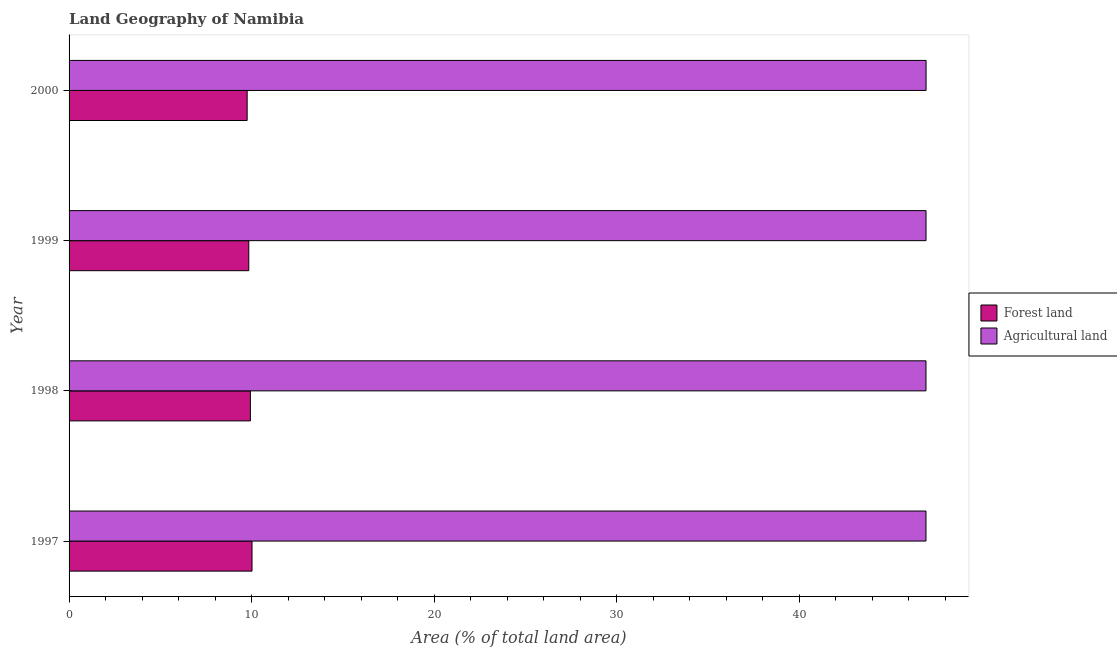How many different coloured bars are there?
Your answer should be compact. 2. Are the number of bars per tick equal to the number of legend labels?
Ensure brevity in your answer.  Yes. How many bars are there on the 4th tick from the bottom?
Make the answer very short. 2. What is the percentage of land area under forests in 1999?
Ensure brevity in your answer.  9.84. Across all years, what is the maximum percentage of land area under agriculture?
Make the answer very short. 46.95. Across all years, what is the minimum percentage of land area under agriculture?
Your answer should be compact. 46.94. In which year was the percentage of land area under agriculture maximum?
Your answer should be compact. 2000. What is the total percentage of land area under forests in the graph?
Your response must be concise. 39.56. What is the difference between the percentage of land area under forests in 1999 and that in 2000?
Keep it short and to the point. 0.09. What is the difference between the percentage of land area under agriculture in 1998 and the percentage of land area under forests in 1997?
Provide a short and direct response. 36.92. What is the average percentage of land area under agriculture per year?
Provide a succinct answer. 46.95. In the year 1999, what is the difference between the percentage of land area under forests and percentage of land area under agriculture?
Keep it short and to the point. -37.1. What is the ratio of the percentage of land area under forests in 1997 to that in 1999?
Your answer should be compact. 1.02. What is the difference between the highest and the second highest percentage of land area under agriculture?
Make the answer very short. 0. Is the sum of the percentage of land area under agriculture in 1998 and 1999 greater than the maximum percentage of land area under forests across all years?
Give a very brief answer. Yes. What does the 2nd bar from the top in 1998 represents?
Keep it short and to the point. Forest land. What does the 2nd bar from the bottom in 2000 represents?
Provide a short and direct response. Agricultural land. How many bars are there?
Keep it short and to the point. 8. Are all the bars in the graph horizontal?
Your answer should be very brief. Yes. How many years are there in the graph?
Your response must be concise. 4. Are the values on the major ticks of X-axis written in scientific E-notation?
Offer a terse response. No. Does the graph contain any zero values?
Your answer should be very brief. No. How are the legend labels stacked?
Your response must be concise. Vertical. What is the title of the graph?
Offer a very short reply. Land Geography of Namibia. What is the label or title of the X-axis?
Offer a terse response. Area (% of total land area). What is the Area (% of total land area) of Forest land in 1997?
Make the answer very short. 10.02. What is the Area (% of total land area) in Agricultural land in 1997?
Your response must be concise. 46.94. What is the Area (% of total land area) of Forest land in 1998?
Offer a terse response. 9.93. What is the Area (% of total land area) of Agricultural land in 1998?
Your answer should be very brief. 46.94. What is the Area (% of total land area) in Forest land in 1999?
Offer a very short reply. 9.84. What is the Area (% of total land area) in Agricultural land in 1999?
Keep it short and to the point. 46.95. What is the Area (% of total land area) of Forest land in 2000?
Your response must be concise. 9.76. What is the Area (% of total land area) of Agricultural land in 2000?
Ensure brevity in your answer.  46.95. Across all years, what is the maximum Area (% of total land area) in Forest land?
Keep it short and to the point. 10.02. Across all years, what is the maximum Area (% of total land area) of Agricultural land?
Your response must be concise. 46.95. Across all years, what is the minimum Area (% of total land area) of Forest land?
Your answer should be very brief. 9.76. Across all years, what is the minimum Area (% of total land area) of Agricultural land?
Keep it short and to the point. 46.94. What is the total Area (% of total land area) in Forest land in the graph?
Your answer should be very brief. 39.56. What is the total Area (% of total land area) in Agricultural land in the graph?
Your response must be concise. 187.79. What is the difference between the Area (% of total land area) of Forest land in 1997 and that in 1998?
Your answer should be compact. 0.09. What is the difference between the Area (% of total land area) of Agricultural land in 1997 and that in 1998?
Keep it short and to the point. 0. What is the difference between the Area (% of total land area) of Forest land in 1997 and that in 1999?
Offer a terse response. 0.18. What is the difference between the Area (% of total land area) in Agricultural land in 1997 and that in 1999?
Give a very brief answer. -0. What is the difference between the Area (% of total land area) in Forest land in 1997 and that in 2000?
Your answer should be very brief. 0.27. What is the difference between the Area (% of total land area) of Agricultural land in 1997 and that in 2000?
Offer a terse response. -0. What is the difference between the Area (% of total land area) in Forest land in 1998 and that in 1999?
Offer a terse response. 0.09. What is the difference between the Area (% of total land area) in Agricultural land in 1998 and that in 1999?
Provide a short and direct response. -0. What is the difference between the Area (% of total land area) of Forest land in 1998 and that in 2000?
Your response must be concise. 0.18. What is the difference between the Area (% of total land area) of Agricultural land in 1998 and that in 2000?
Give a very brief answer. -0. What is the difference between the Area (% of total land area) in Forest land in 1999 and that in 2000?
Ensure brevity in your answer.  0.09. What is the difference between the Area (% of total land area) of Agricultural land in 1999 and that in 2000?
Your answer should be very brief. -0. What is the difference between the Area (% of total land area) in Forest land in 1997 and the Area (% of total land area) in Agricultural land in 1998?
Your response must be concise. -36.92. What is the difference between the Area (% of total land area) in Forest land in 1997 and the Area (% of total land area) in Agricultural land in 1999?
Make the answer very short. -36.92. What is the difference between the Area (% of total land area) in Forest land in 1997 and the Area (% of total land area) in Agricultural land in 2000?
Keep it short and to the point. -36.93. What is the difference between the Area (% of total land area) of Forest land in 1998 and the Area (% of total land area) of Agricultural land in 1999?
Your response must be concise. -37.01. What is the difference between the Area (% of total land area) in Forest land in 1998 and the Area (% of total land area) in Agricultural land in 2000?
Give a very brief answer. -37.02. What is the difference between the Area (% of total land area) in Forest land in 1999 and the Area (% of total land area) in Agricultural land in 2000?
Offer a terse response. -37.1. What is the average Area (% of total land area) in Forest land per year?
Keep it short and to the point. 9.89. What is the average Area (% of total land area) of Agricultural land per year?
Give a very brief answer. 46.95. In the year 1997, what is the difference between the Area (% of total land area) in Forest land and Area (% of total land area) in Agricultural land?
Make the answer very short. -36.92. In the year 1998, what is the difference between the Area (% of total land area) of Forest land and Area (% of total land area) of Agricultural land?
Offer a very short reply. -37.01. In the year 1999, what is the difference between the Area (% of total land area) in Forest land and Area (% of total land area) in Agricultural land?
Your response must be concise. -37.1. In the year 2000, what is the difference between the Area (% of total land area) of Forest land and Area (% of total land area) of Agricultural land?
Offer a terse response. -37.19. What is the ratio of the Area (% of total land area) of Forest land in 1997 to that in 1998?
Keep it short and to the point. 1.01. What is the ratio of the Area (% of total land area) of Agricultural land in 1997 to that in 1998?
Provide a short and direct response. 1. What is the ratio of the Area (% of total land area) in Forest land in 1997 to that in 1999?
Your answer should be very brief. 1.02. What is the ratio of the Area (% of total land area) of Forest land in 1997 to that in 2000?
Give a very brief answer. 1.03. What is the ratio of the Area (% of total land area) in Agricultural land in 1997 to that in 2000?
Provide a succinct answer. 1. What is the ratio of the Area (% of total land area) in Forest land in 1998 to that in 1999?
Make the answer very short. 1.01. What is the ratio of the Area (% of total land area) in Forest land in 1998 to that in 2000?
Offer a terse response. 1.02. What is the ratio of the Area (% of total land area) in Forest land in 1999 to that in 2000?
Give a very brief answer. 1.01. What is the difference between the highest and the second highest Area (% of total land area) of Forest land?
Your response must be concise. 0.09. What is the difference between the highest and the second highest Area (% of total land area) of Agricultural land?
Keep it short and to the point. 0. What is the difference between the highest and the lowest Area (% of total land area) of Forest land?
Keep it short and to the point. 0.27. What is the difference between the highest and the lowest Area (% of total land area) in Agricultural land?
Your response must be concise. 0. 